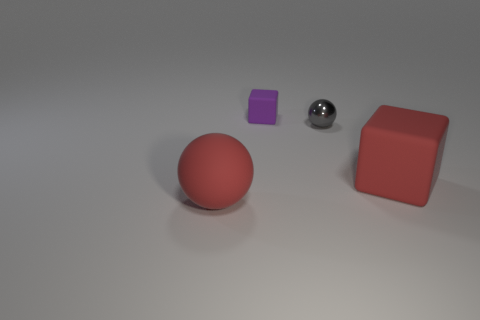Could you estimate the relative sizes of the objects based on perspective? Based on perspective and assuming the objects are positioned relatively close to each other, the red sphere appears to be the largest, followed by the red cube and the metallic gray sphere. The purple cube seems to be the smallest object in the scene. 